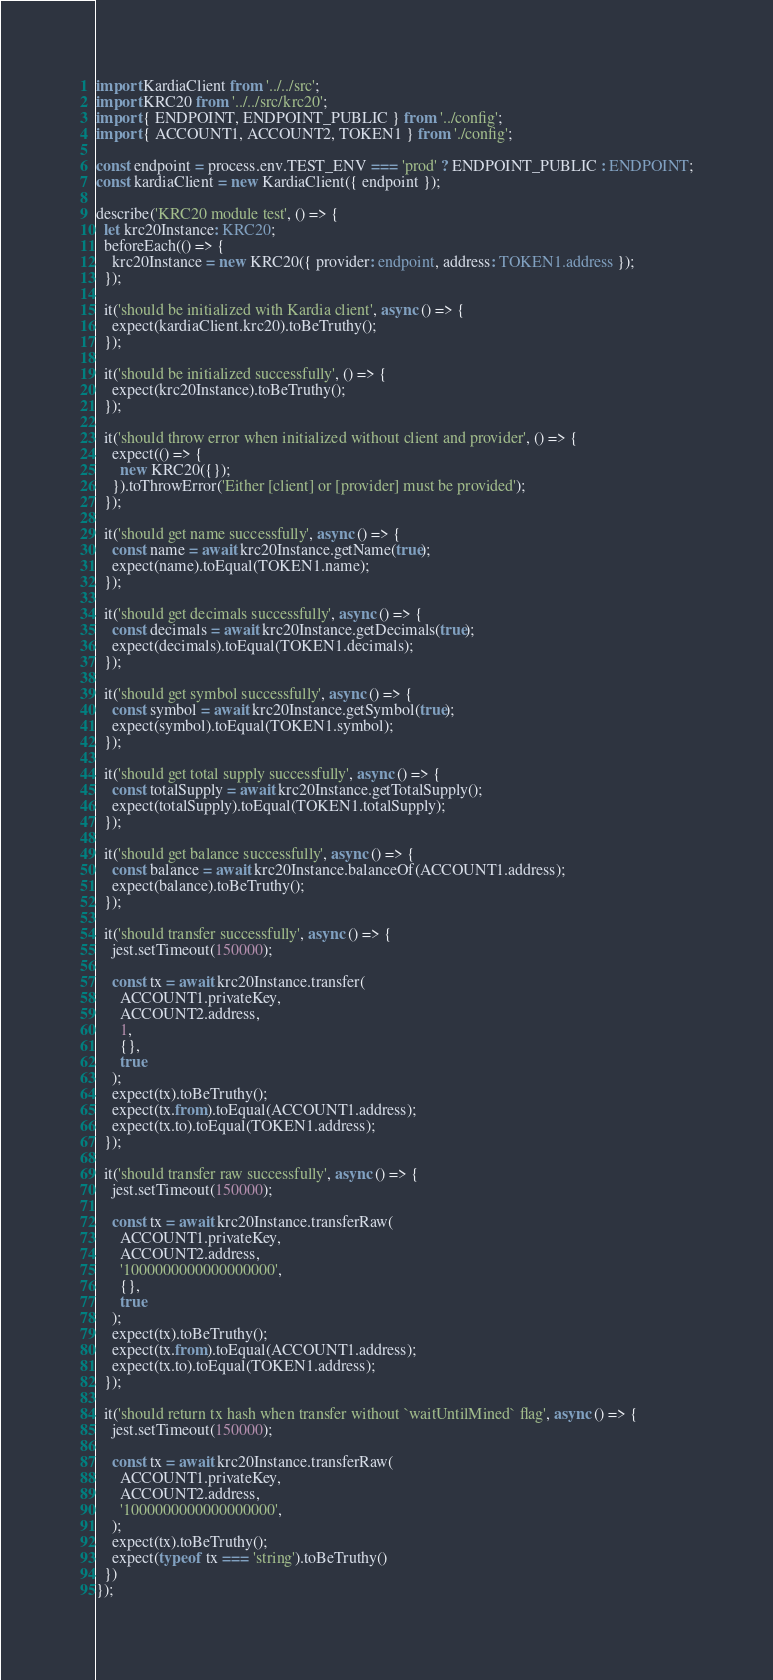Convert code to text. <code><loc_0><loc_0><loc_500><loc_500><_TypeScript_>import KardiaClient from '../../src';
import KRC20 from '../../src/krc20';
import { ENDPOINT, ENDPOINT_PUBLIC } from '../config';
import { ACCOUNT1, ACCOUNT2, TOKEN1 } from './config';

const endpoint = process.env.TEST_ENV === 'prod' ? ENDPOINT_PUBLIC : ENDPOINT;
const kardiaClient = new KardiaClient({ endpoint });

describe('KRC20 module test', () => {
  let krc20Instance: KRC20;
  beforeEach(() => {
    krc20Instance = new KRC20({ provider: endpoint, address: TOKEN1.address });
  });

  it('should be initialized with Kardia client', async () => {
    expect(kardiaClient.krc20).toBeTruthy();
  });

  it('should be initialized successfully', () => {
    expect(krc20Instance).toBeTruthy();
  });

  it('should throw error when initialized without client and provider', () => {
    expect(() => {
      new KRC20({});
    }).toThrowError('Either [client] or [provider] must be provided');
  });

  it('should get name successfully', async () => {
    const name = await krc20Instance.getName(true);
    expect(name).toEqual(TOKEN1.name);
  });

  it('should get decimals successfully', async () => {
    const decimals = await krc20Instance.getDecimals(true);
    expect(decimals).toEqual(TOKEN1.decimals);
  });

  it('should get symbol successfully', async () => {
    const symbol = await krc20Instance.getSymbol(true);
    expect(symbol).toEqual(TOKEN1.symbol);
  });

  it('should get total supply successfully', async () => {
    const totalSupply = await krc20Instance.getTotalSupply();
    expect(totalSupply).toEqual(TOKEN1.totalSupply);
  });

  it('should get balance successfully', async () => {
    const balance = await krc20Instance.balanceOf(ACCOUNT1.address);
    expect(balance).toBeTruthy();
  });

  it('should transfer successfully', async () => {
    jest.setTimeout(150000);

    const tx = await krc20Instance.transfer(
      ACCOUNT1.privateKey,
      ACCOUNT2.address,
      1,
      {},
      true
    );
    expect(tx).toBeTruthy();
    expect(tx.from).toEqual(ACCOUNT1.address);
    expect(tx.to).toEqual(TOKEN1.address);
  });

  it('should transfer raw successfully', async () => {
    jest.setTimeout(150000);

    const tx = await krc20Instance.transferRaw(
      ACCOUNT1.privateKey,
      ACCOUNT2.address,
      '1000000000000000000',
      {},
      true
    );
    expect(tx).toBeTruthy();
    expect(tx.from).toEqual(ACCOUNT1.address);
    expect(tx.to).toEqual(TOKEN1.address);
  });

  it('should return tx hash when transfer without `waitUntilMined` flag', async () => {
    jest.setTimeout(150000);

    const tx = await krc20Instance.transferRaw(
      ACCOUNT1.privateKey,
      ACCOUNT2.address,
      '1000000000000000000',
    );
    expect(tx).toBeTruthy();
    expect(typeof tx === 'string').toBeTruthy()
  })
});
</code> 